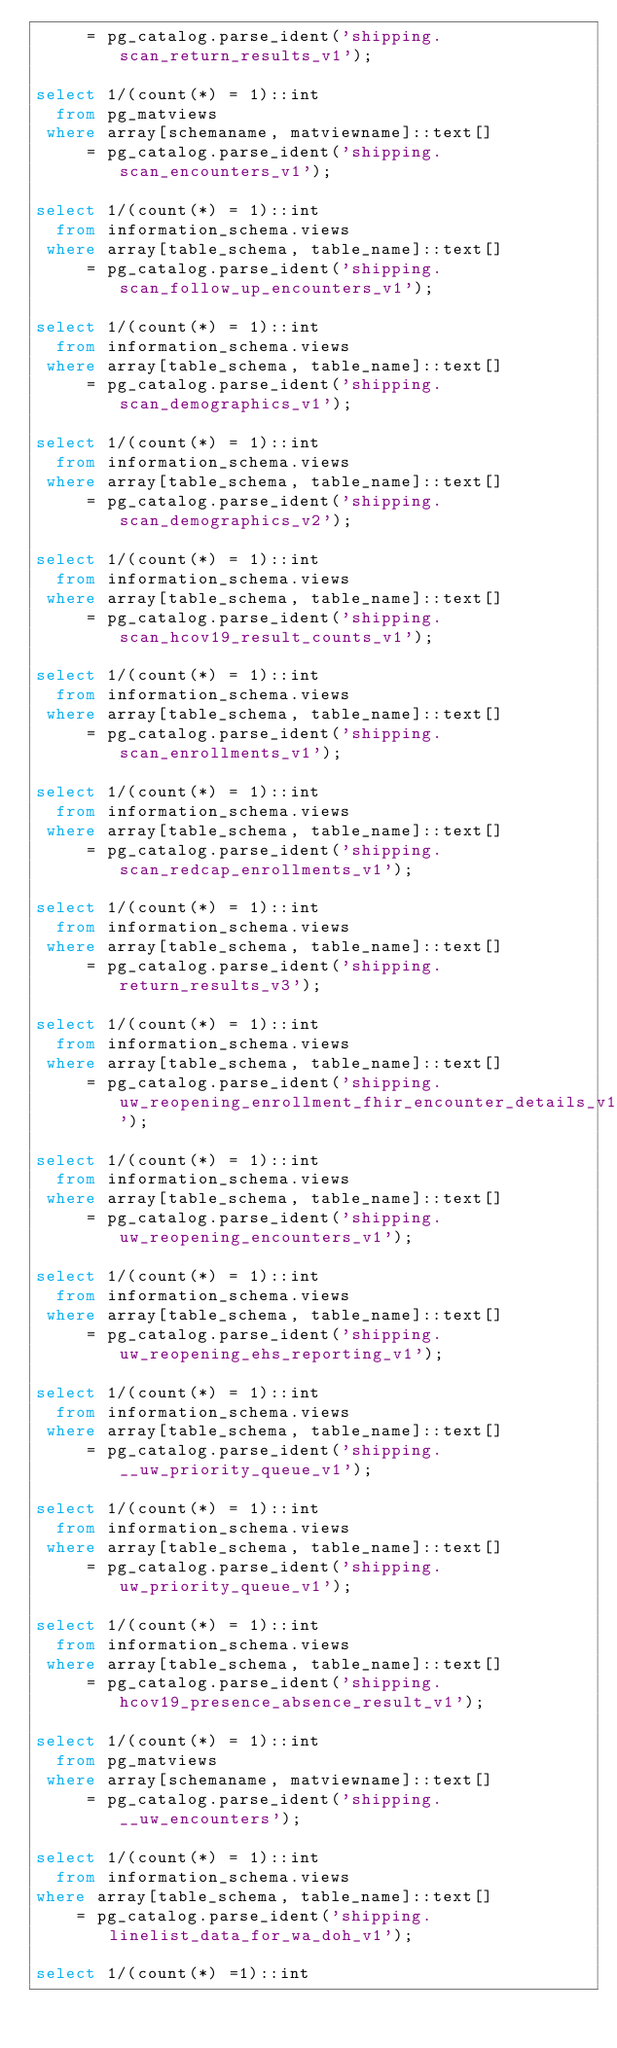<code> <loc_0><loc_0><loc_500><loc_500><_SQL_>     = pg_catalog.parse_ident('shipping.scan_return_results_v1');

select 1/(count(*) = 1)::int
  from pg_matviews
 where array[schemaname, matviewname]::text[]
     = pg_catalog.parse_ident('shipping.scan_encounters_v1');

select 1/(count(*) = 1)::int
  from information_schema.views
 where array[table_schema, table_name]::text[]
     = pg_catalog.parse_ident('shipping.scan_follow_up_encounters_v1');

select 1/(count(*) = 1)::int
  from information_schema.views
 where array[table_schema, table_name]::text[]
     = pg_catalog.parse_ident('shipping.scan_demographics_v1');

select 1/(count(*) = 1)::int
  from information_schema.views
 where array[table_schema, table_name]::text[]
     = pg_catalog.parse_ident('shipping.scan_demographics_v2');

select 1/(count(*) = 1)::int
  from information_schema.views
 where array[table_schema, table_name]::text[]
     = pg_catalog.parse_ident('shipping.scan_hcov19_result_counts_v1');

select 1/(count(*) = 1)::int
  from information_schema.views
 where array[table_schema, table_name]::text[]
     = pg_catalog.parse_ident('shipping.scan_enrollments_v1');

select 1/(count(*) = 1)::int
  from information_schema.views
 where array[table_schema, table_name]::text[]
     = pg_catalog.parse_ident('shipping.scan_redcap_enrollments_v1');

select 1/(count(*) = 1)::int
  from information_schema.views
 where array[table_schema, table_name]::text[]
     = pg_catalog.parse_ident('shipping.return_results_v3');

select 1/(count(*) = 1)::int
  from information_schema.views
 where array[table_schema, table_name]::text[]
     = pg_catalog.parse_ident('shipping.uw_reopening_enrollment_fhir_encounter_details_v1');

select 1/(count(*) = 1)::int
  from information_schema.views
 where array[table_schema, table_name]::text[]
     = pg_catalog.parse_ident('shipping.uw_reopening_encounters_v1');

select 1/(count(*) = 1)::int
  from information_schema.views
 where array[table_schema, table_name]::text[]
     = pg_catalog.parse_ident('shipping.uw_reopening_ehs_reporting_v1');

select 1/(count(*) = 1)::int
  from information_schema.views
 where array[table_schema, table_name]::text[]
     = pg_catalog.parse_ident('shipping.__uw_priority_queue_v1');

select 1/(count(*) = 1)::int
  from information_schema.views
 where array[table_schema, table_name]::text[]
     = pg_catalog.parse_ident('shipping.uw_priority_queue_v1');

select 1/(count(*) = 1)::int
  from information_schema.views
 where array[table_schema, table_name]::text[]
     = pg_catalog.parse_ident('shipping.hcov19_presence_absence_result_v1');

select 1/(count(*) = 1)::int
  from pg_matviews
 where array[schemaname, matviewname]::text[]
     = pg_catalog.parse_ident('shipping.__uw_encounters');

select 1/(count(*) = 1)::int
  from information_schema.views
where array[table_schema, table_name]::text[]
    = pg_catalog.parse_ident('shipping.linelist_data_for_wa_doh_v1');

select 1/(count(*) =1)::int</code> 